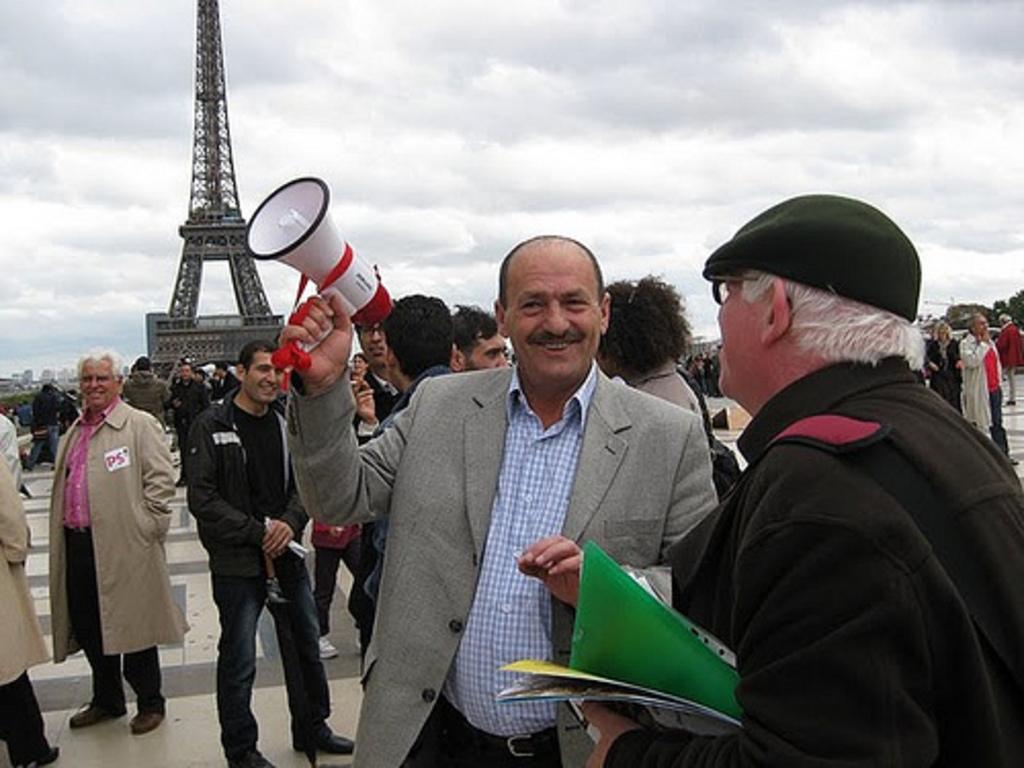How would you summarize this image in a sentence or two? In front of the image there are two people, one of them is holding a mic and the other one is holding some papers, behind them there are a few other people, in the background of the image there are trees, buildings and an Eiffel tower, at the top of the image there are clouds in the sky. 